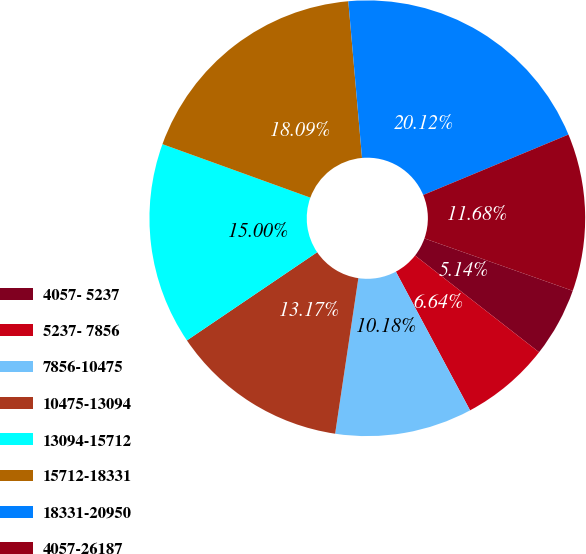Convert chart to OTSL. <chart><loc_0><loc_0><loc_500><loc_500><pie_chart><fcel>4057- 5237<fcel>5237- 7856<fcel>7856-10475<fcel>10475-13094<fcel>13094-15712<fcel>15712-18331<fcel>18331-20950<fcel>4057-26187<nl><fcel>5.14%<fcel>6.64%<fcel>10.18%<fcel>13.17%<fcel>15.0%<fcel>18.09%<fcel>20.12%<fcel>11.68%<nl></chart> 